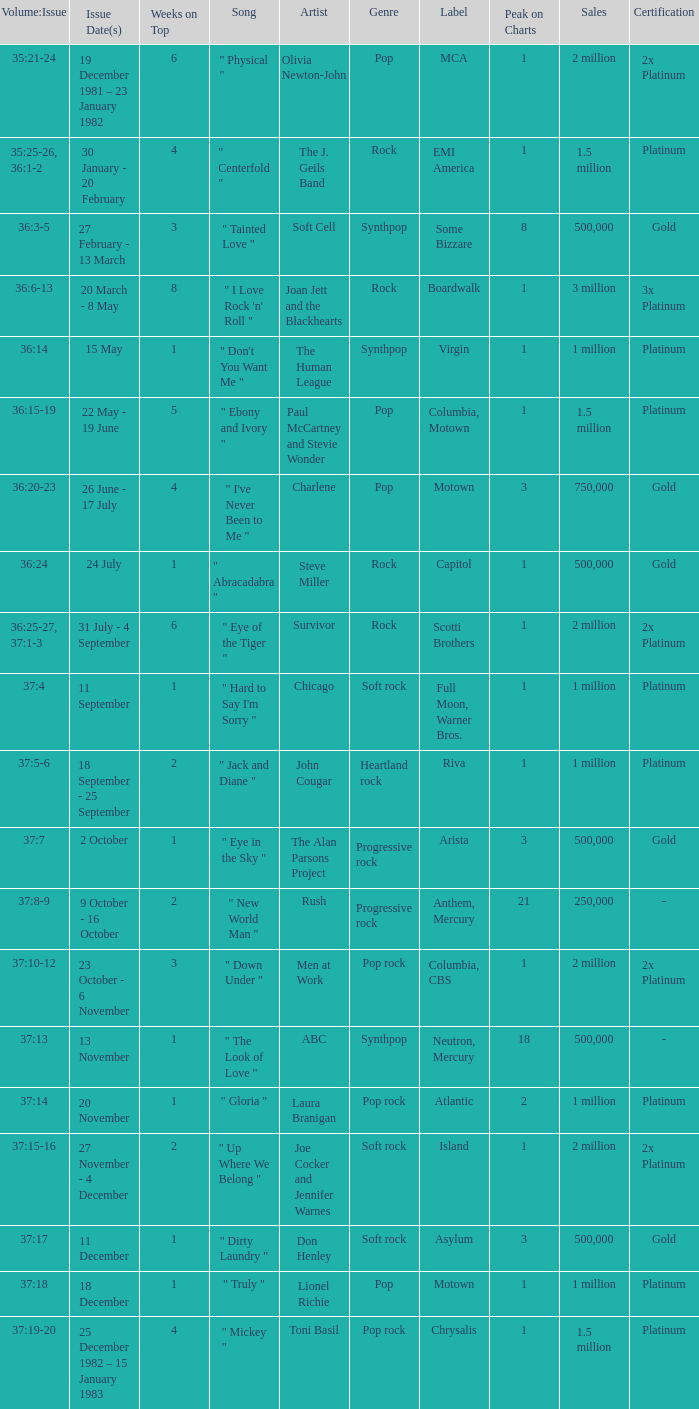Could you parse the entire table? {'header': ['Volume:Issue', 'Issue Date(s)', 'Weeks on Top', 'Song', 'Artist', 'Genre', 'Label', 'Peak on Charts', 'Sales', 'Certification'], 'rows': [['35:21-24', '19 December 1981 – 23 January 1982', '6', '" Physical "', 'Olivia Newton-John', 'Pop', 'MCA', '1', '2 million', '2x Platinum'], ['35:25-26, 36:1-2', '30 January - 20 February', '4', '" Centerfold "', 'The J. Geils Band', 'Rock', 'EMI America', '1', '1.5 million', 'Platinum'], ['36:3-5', '27 February - 13 March', '3', '" Tainted Love "', 'Soft Cell', 'Synthpop', 'Some Bizzare', '8', '500,000', 'Gold'], ['36:6-13', '20 March - 8 May', '8', '" I Love Rock \'n\' Roll "', 'Joan Jett and the Blackhearts', 'Rock', 'Boardwalk', '1', '3 million', '3x Platinum'], ['36:14', '15 May', '1', '" Don\'t You Want Me "', 'The Human League', 'Synthpop', 'Virgin', '1', '1 million', 'Platinum'], ['36:15-19', '22 May - 19 June', '5', '" Ebony and Ivory "', 'Paul McCartney and Stevie Wonder', 'Pop', 'Columbia, Motown', '1', '1.5 million', 'Platinum'], ['36:20-23', '26 June - 17 July', '4', '" I\'ve Never Been to Me "', 'Charlene', 'Pop', 'Motown', '3', '750,000', 'Gold'], ['36:24', '24 July', '1', '" Abracadabra "', 'Steve Miller', 'Rock', 'Capitol', '1', '500,000', 'Gold'], ['36:25-27, 37:1-3', '31 July - 4 September', '6', '" Eye of the Tiger "', 'Survivor', 'Rock', 'Scotti Brothers', '1', '2 million', '2x Platinum'], ['37:4', '11 September', '1', '" Hard to Say I\'m Sorry "', 'Chicago', 'Soft rock', 'Full Moon, Warner Bros.', '1', '1 million', 'Platinum'], ['37:5-6', '18 September - 25 September', '2', '" Jack and Diane "', 'John Cougar', 'Heartland rock', 'Riva', '1', '1 million', 'Platinum'], ['37:7', '2 October', '1', '" Eye in the Sky "', 'The Alan Parsons Project', 'Progressive rock', 'Arista', '3', '500,000', 'Gold'], ['37:8-9', '9 October - 16 October', '2', '" New World Man "', 'Rush', 'Progressive rock', 'Anthem, Mercury', '21', '250,000', '-'], ['37:10-12', '23 October - 6 November', '3', '" Down Under "', 'Men at Work', 'Pop rock', 'Columbia, CBS', '1', '2 million', '2x Platinum'], ['37:13', '13 November', '1', '" The Look of Love "', 'ABC', 'Synthpop', 'Neutron, Mercury', '18', '500,000', '-'], ['37:14', '20 November', '1', '" Gloria "', 'Laura Branigan', 'Pop rock', 'Atlantic', '2', '1 million', 'Platinum'], ['37:15-16', '27 November - 4 December', '2', '" Up Where We Belong "', 'Joe Cocker and Jennifer Warnes', 'Soft rock', 'Island', '1', '2 million', '2x Platinum'], ['37:17', '11 December', '1', '" Dirty Laundry "', 'Don Henley', 'Soft rock', 'Asylum', '3', '500,000', 'Gold'], ['37:18', '18 December', '1', '" Truly "', 'Lionel Richie', 'Pop', 'Motown', '1', '1 million', 'Platinum'], ['37:19-20', '25 December 1982 – 15 January 1983', '4', '" Mickey "', 'Toni Basil', 'Pop rock', 'Chrysalis', '1', '1.5 million', 'Platinum']]} Which Issue Date(s) has Weeks on Top larger than 3, and a Volume: Issue of 35:25-26, 36:1-2? 30 January - 20 February. 